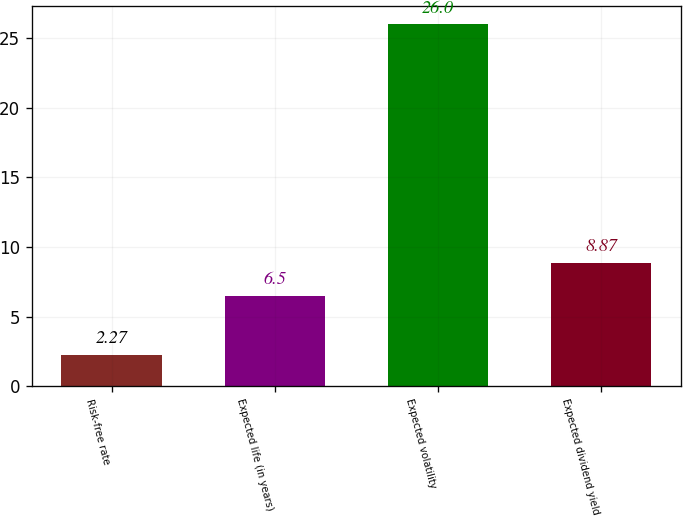Convert chart to OTSL. <chart><loc_0><loc_0><loc_500><loc_500><bar_chart><fcel>Risk-free rate<fcel>Expected life (in years)<fcel>Expected volatility<fcel>Expected dividend yield<nl><fcel>2.27<fcel>6.5<fcel>26<fcel>8.87<nl></chart> 